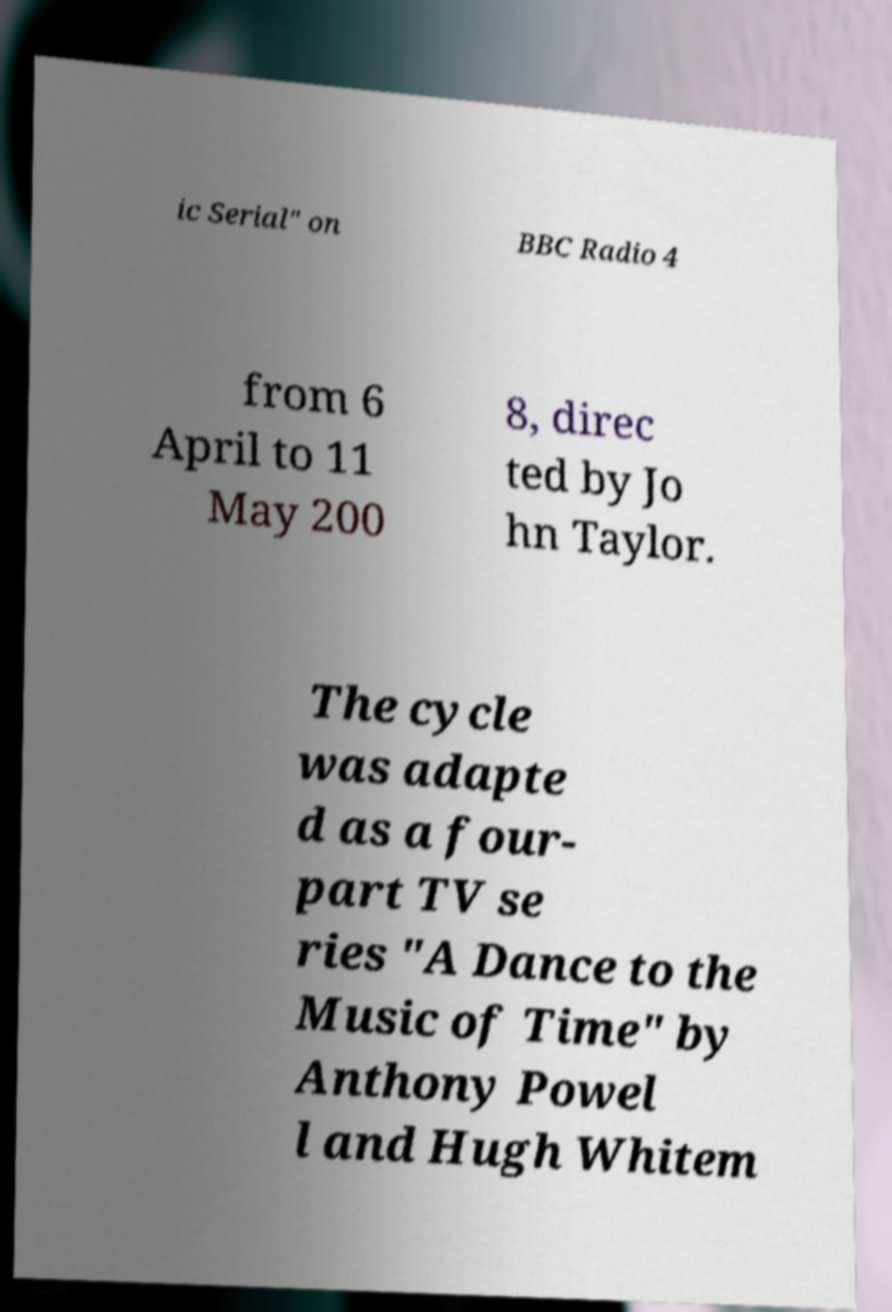Can you accurately transcribe the text from the provided image for me? ic Serial" on BBC Radio 4 from 6 April to 11 May 200 8, direc ted by Jo hn Taylor. The cycle was adapte d as a four- part TV se ries "A Dance to the Music of Time" by Anthony Powel l and Hugh Whitem 